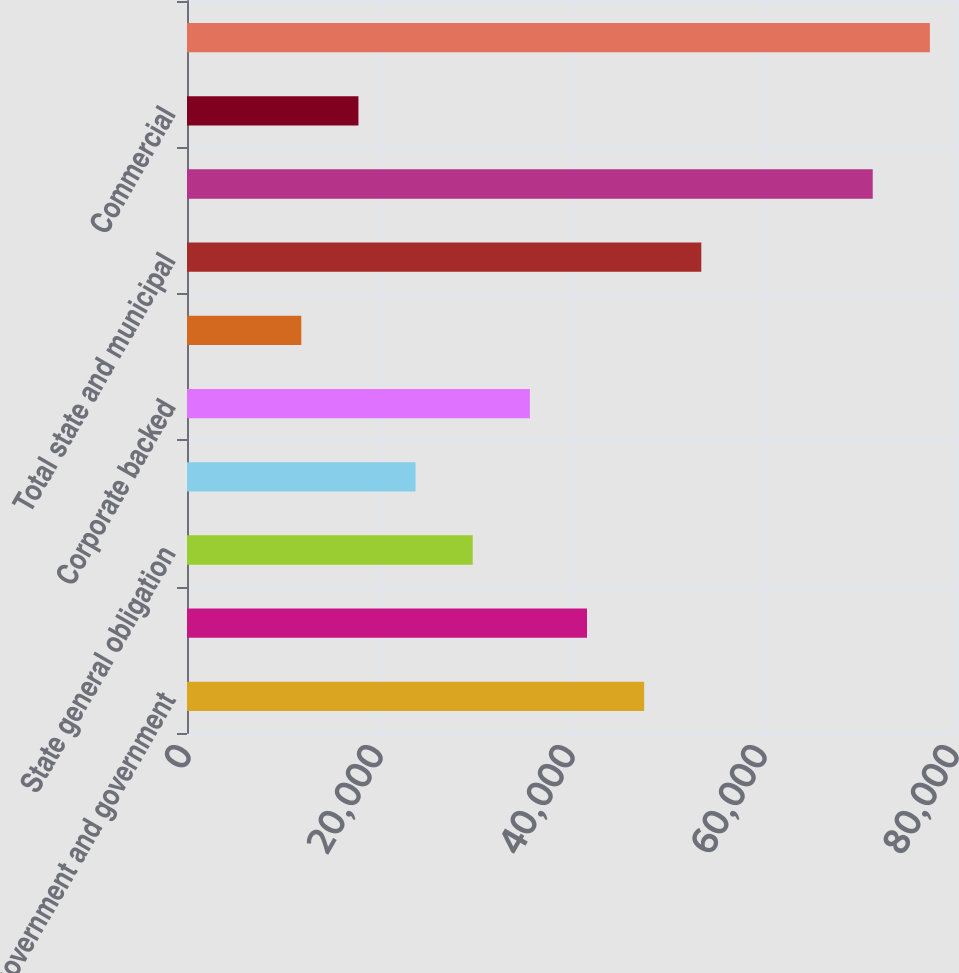Convert chart to OTSL. <chart><loc_0><loc_0><loc_500><loc_500><bar_chart><fcel>US government and government<fcel>Special revenue<fcel>State general obligation<fcel>Pre-refunded<fcel>Corporate backed<fcel>Local general obligation<fcel>Total state and municipal<fcel>Residential (1)<fcel>Commercial<fcel>Total mortgage-backed<nl><fcel>47619.4<fcel>41667.1<fcel>29762.5<fcel>23810.2<fcel>35714.8<fcel>11905.6<fcel>53571.7<fcel>71428.6<fcel>17857.9<fcel>77380.9<nl></chart> 